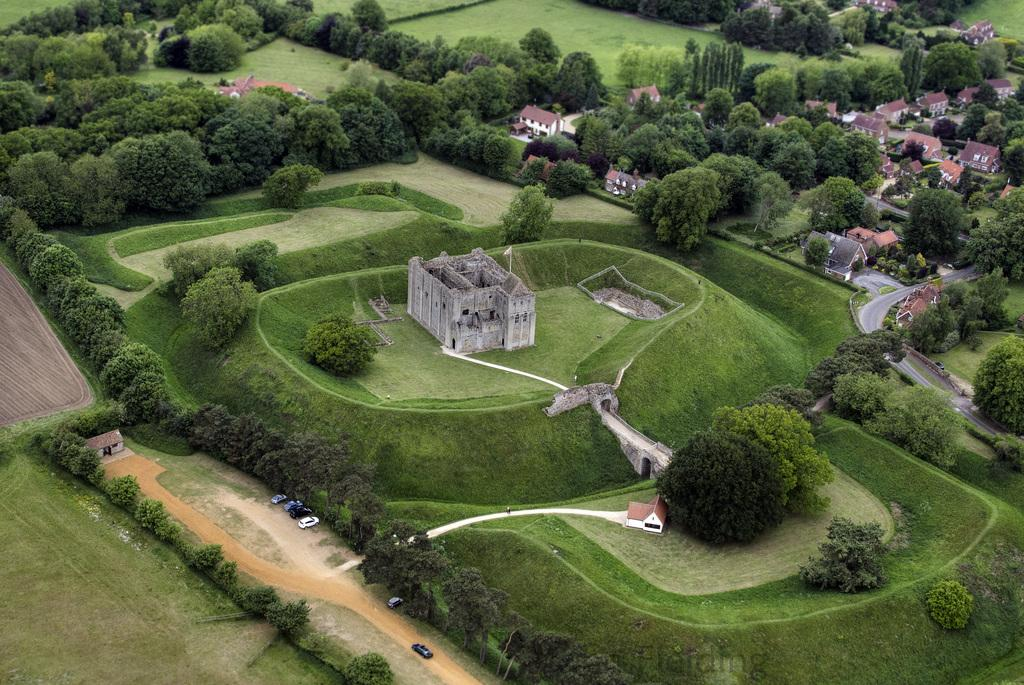What type of structures can be seen in the image? There are buildings in the image. What natural elements are present in the image? There are trees in the image. What is on top of one of the buildings? There is a flag on top of a building. What type of transportation can be seen in the image? There are vehicles in the image. What type of vegetation is at the bottom of the image? There is grass at the bottom of the image. What type of surface is visible in the image? There is ground visible in the image. Can you tell me how many snakes are slithering on the ground in the image? There are no snakes present in the image; it features buildings, trees, a flag, vehicles, grass, and ground. What type of currency is visible in the image? There is no currency visible in the image. 